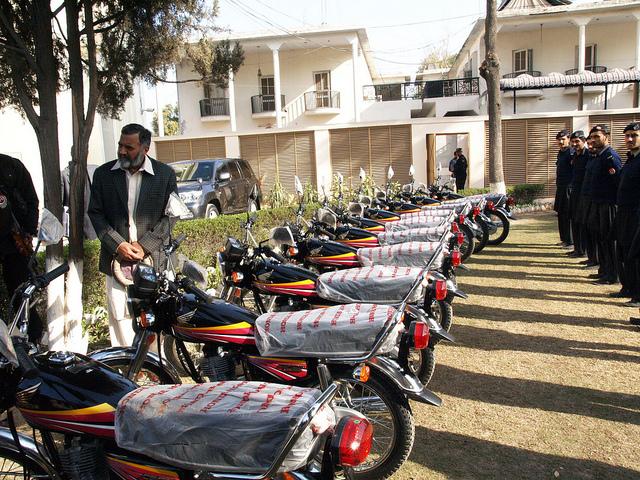What color is the second scooter?
Write a very short answer. Black. Is this the USA?
Quick response, please. No. What are the bike seats covered with?
Give a very brief answer. Plastic. What do these vehicles do?
Quick response, please. Drive. Can you count all these motorbikes?
Answer briefly. Yes. 